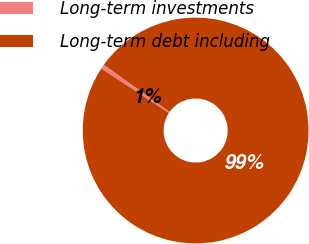Convert chart to OTSL. <chart><loc_0><loc_0><loc_500><loc_500><pie_chart><fcel>Long-term investments<fcel>Long-term debt including<nl><fcel>0.64%<fcel>99.36%<nl></chart> 